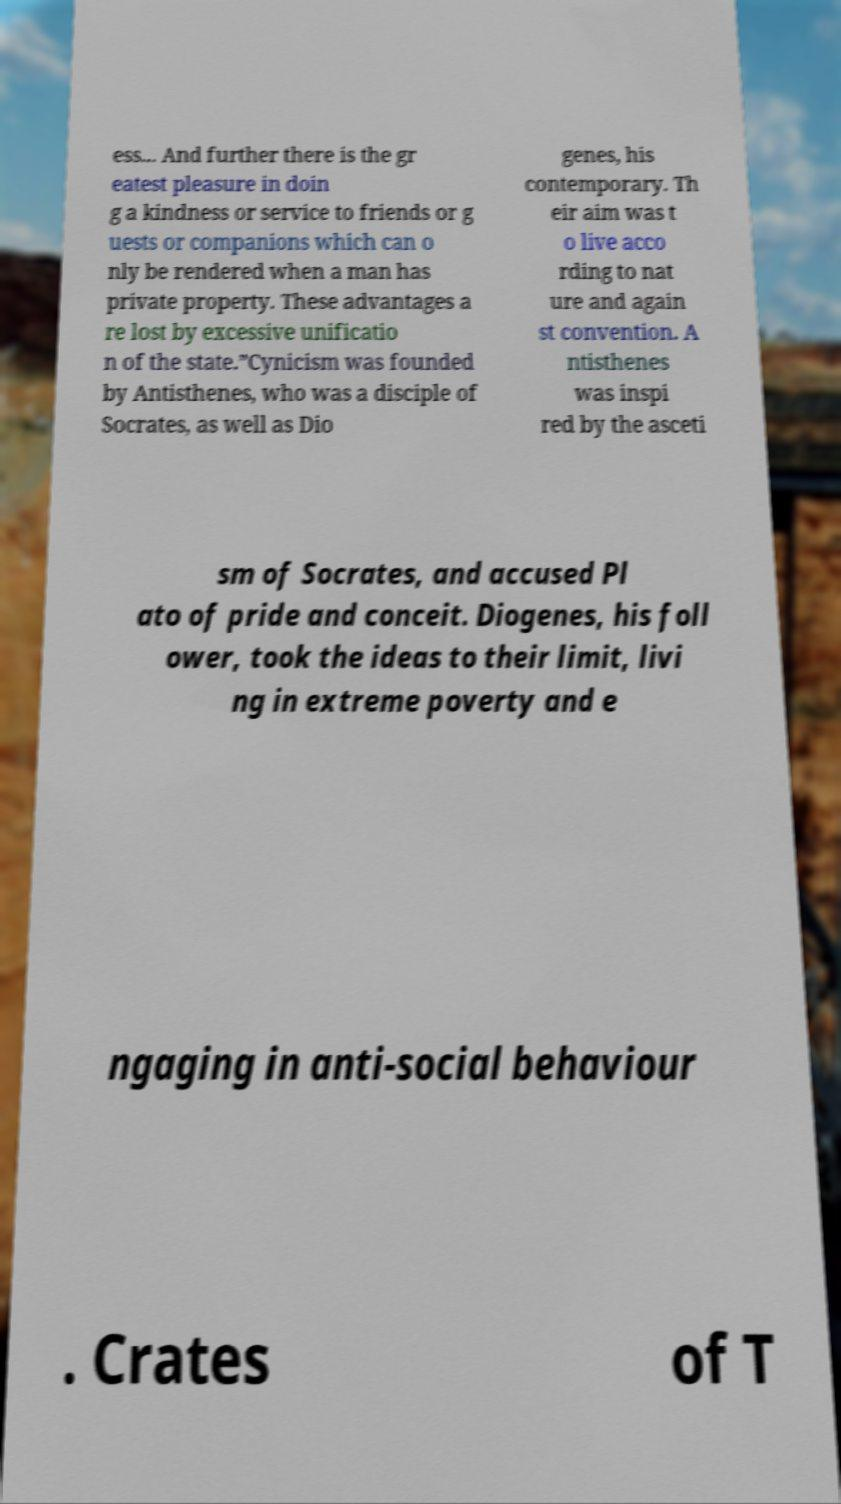Can you accurately transcribe the text from the provided image for me? ess... And further there is the gr eatest pleasure in doin g a kindness or service to friends or g uests or companions which can o nly be rendered when a man has private property. These advantages a re lost by excessive unificatio n of the state.”Cynicism was founded by Antisthenes, who was a disciple of Socrates, as well as Dio genes, his contemporary. Th eir aim was t o live acco rding to nat ure and again st convention. A ntisthenes was inspi red by the asceti sm of Socrates, and accused Pl ato of pride and conceit. Diogenes, his foll ower, took the ideas to their limit, livi ng in extreme poverty and e ngaging in anti-social behaviour . Crates of T 